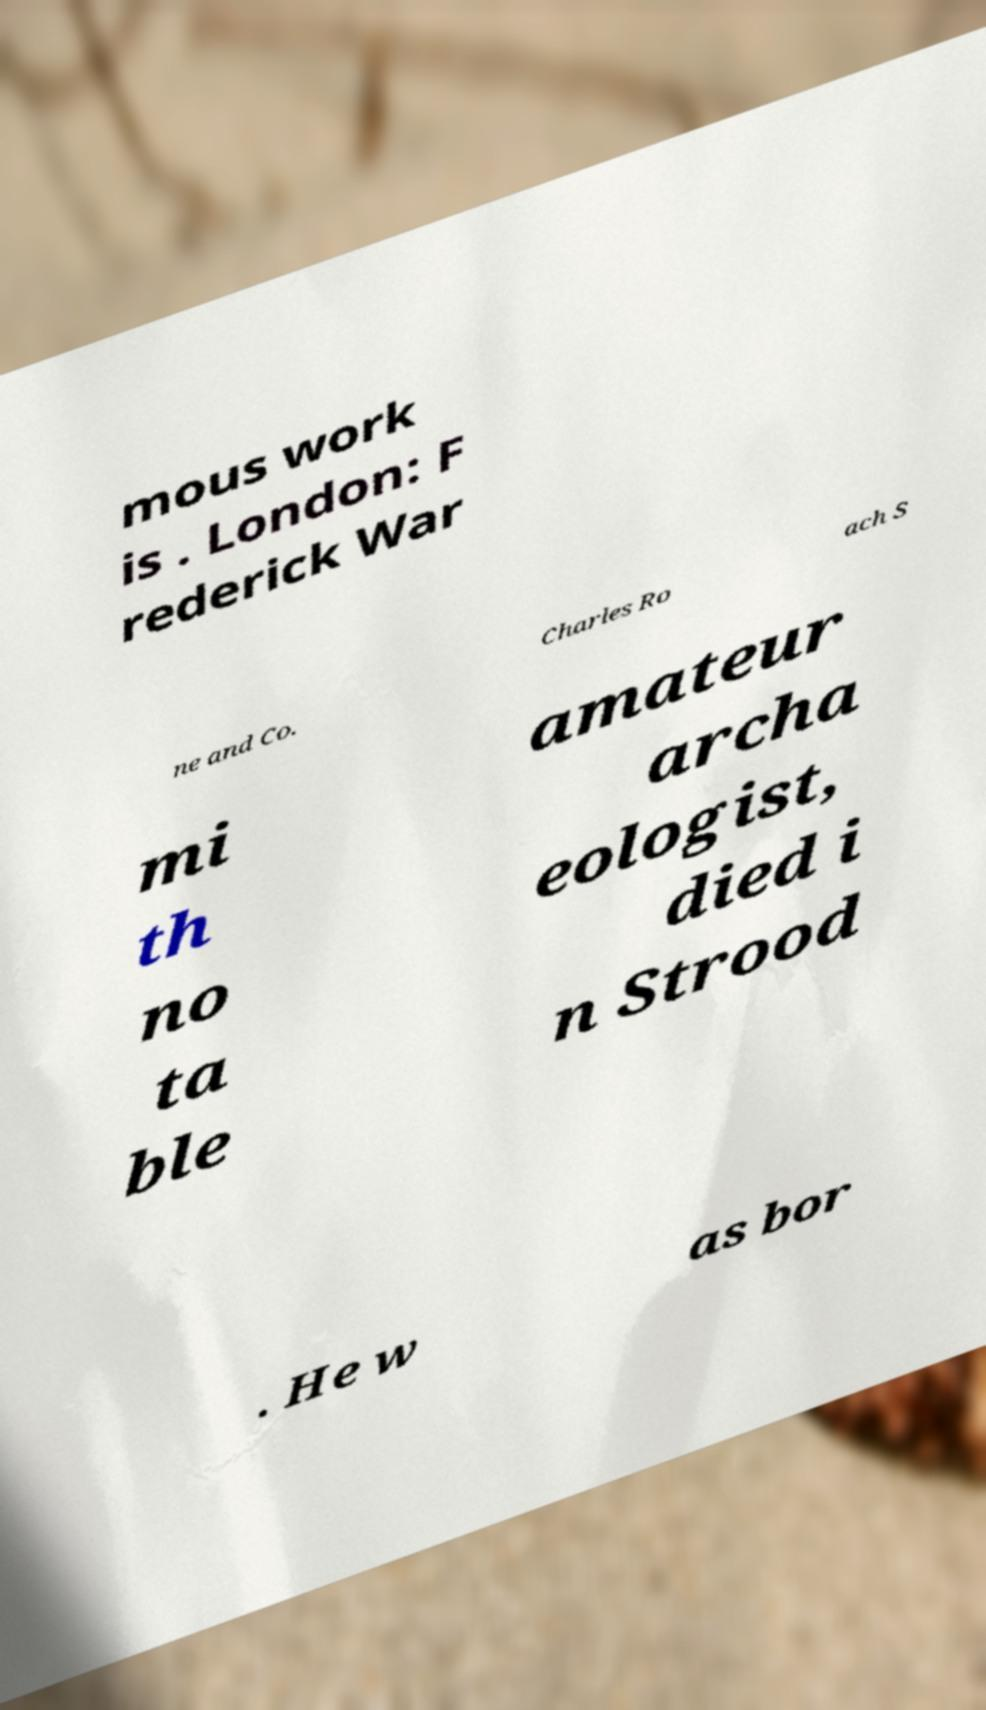Can you accurately transcribe the text from the provided image for me? mous work is . London: F rederick War ne and Co. Charles Ro ach S mi th no ta ble amateur archa eologist, died i n Strood . He w as bor 